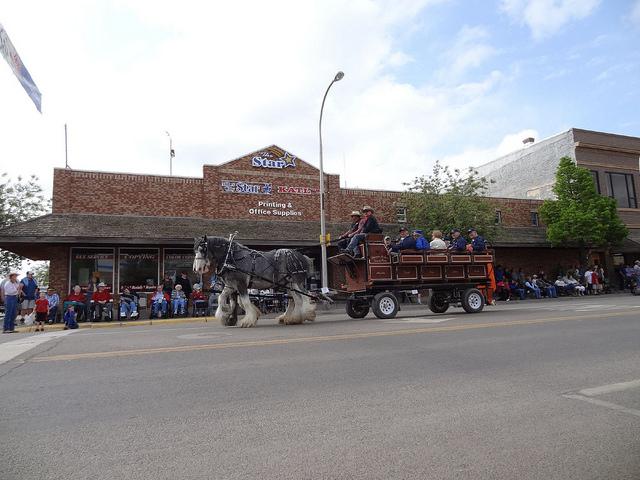What is the horse pulling?
Be succinct. Wagon. Are those residences or businesses in the buildings?
Concise answer only. Businesses. Where is the person in jeans?
Be succinct. Sidewalk. What is beside the horse?
Short answer required. Wagon. What kind of animals are walking in the road?
Be succinct. Horses. What brand are these horses usually associated with?
Answer briefly. Budweiser. Are the bicycles parked too close to the street?
Quick response, please. No. What animals are being herded down the road?
Quick response, please. Horses. What is the vehicle coming in?
Be succinct. Wagon. Is this a parade?
Answer briefly. Yes. How many horses are there?
Short answer required. 2. 